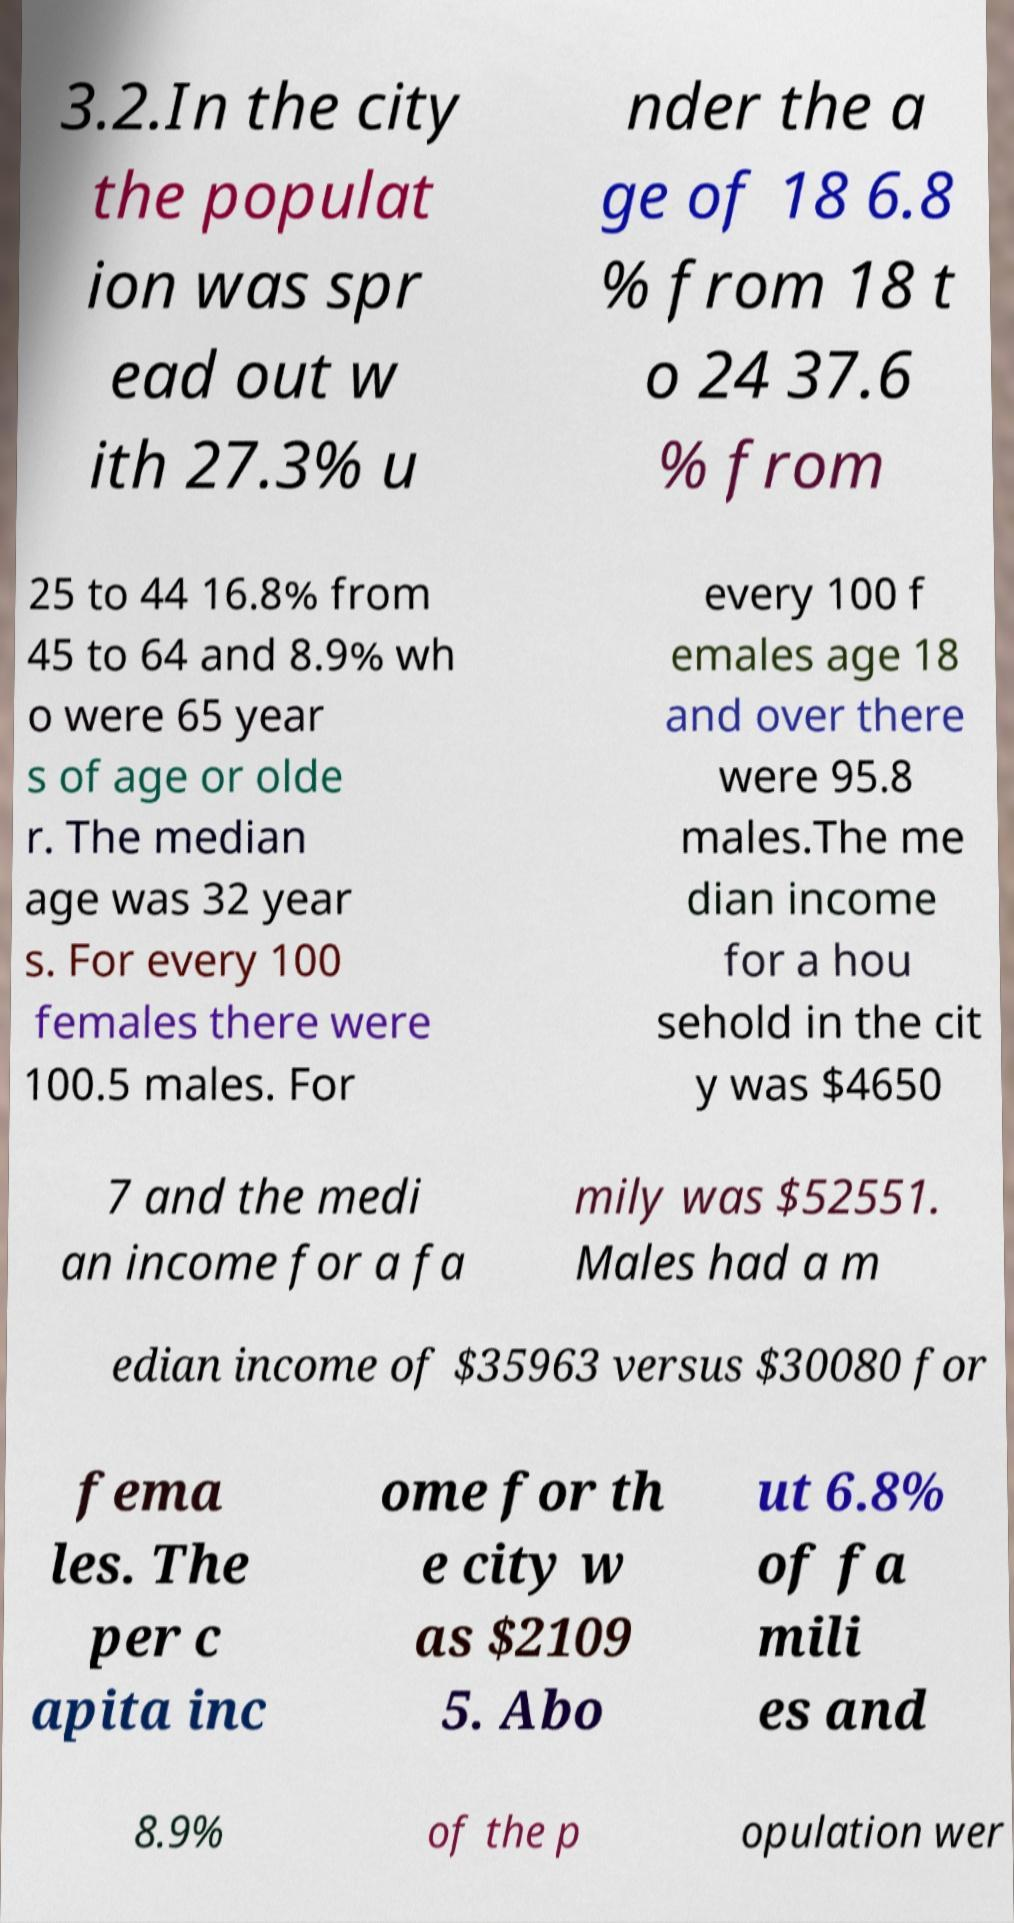Please identify and transcribe the text found in this image. 3.2.In the city the populat ion was spr ead out w ith 27.3% u nder the a ge of 18 6.8 % from 18 t o 24 37.6 % from 25 to 44 16.8% from 45 to 64 and 8.9% wh o were 65 year s of age or olde r. The median age was 32 year s. For every 100 females there were 100.5 males. For every 100 f emales age 18 and over there were 95.8 males.The me dian income for a hou sehold in the cit y was $4650 7 and the medi an income for a fa mily was $52551. Males had a m edian income of $35963 versus $30080 for fema les. The per c apita inc ome for th e city w as $2109 5. Abo ut 6.8% of fa mili es and 8.9% of the p opulation wer 